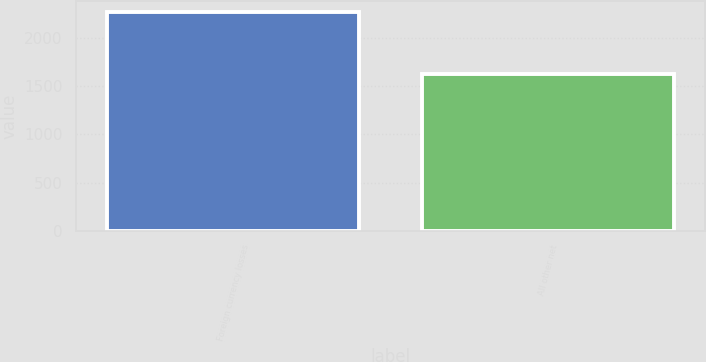<chart> <loc_0><loc_0><loc_500><loc_500><bar_chart><fcel>Foreign currency losses<fcel>All other net<nl><fcel>2270<fcel>1630<nl></chart> 